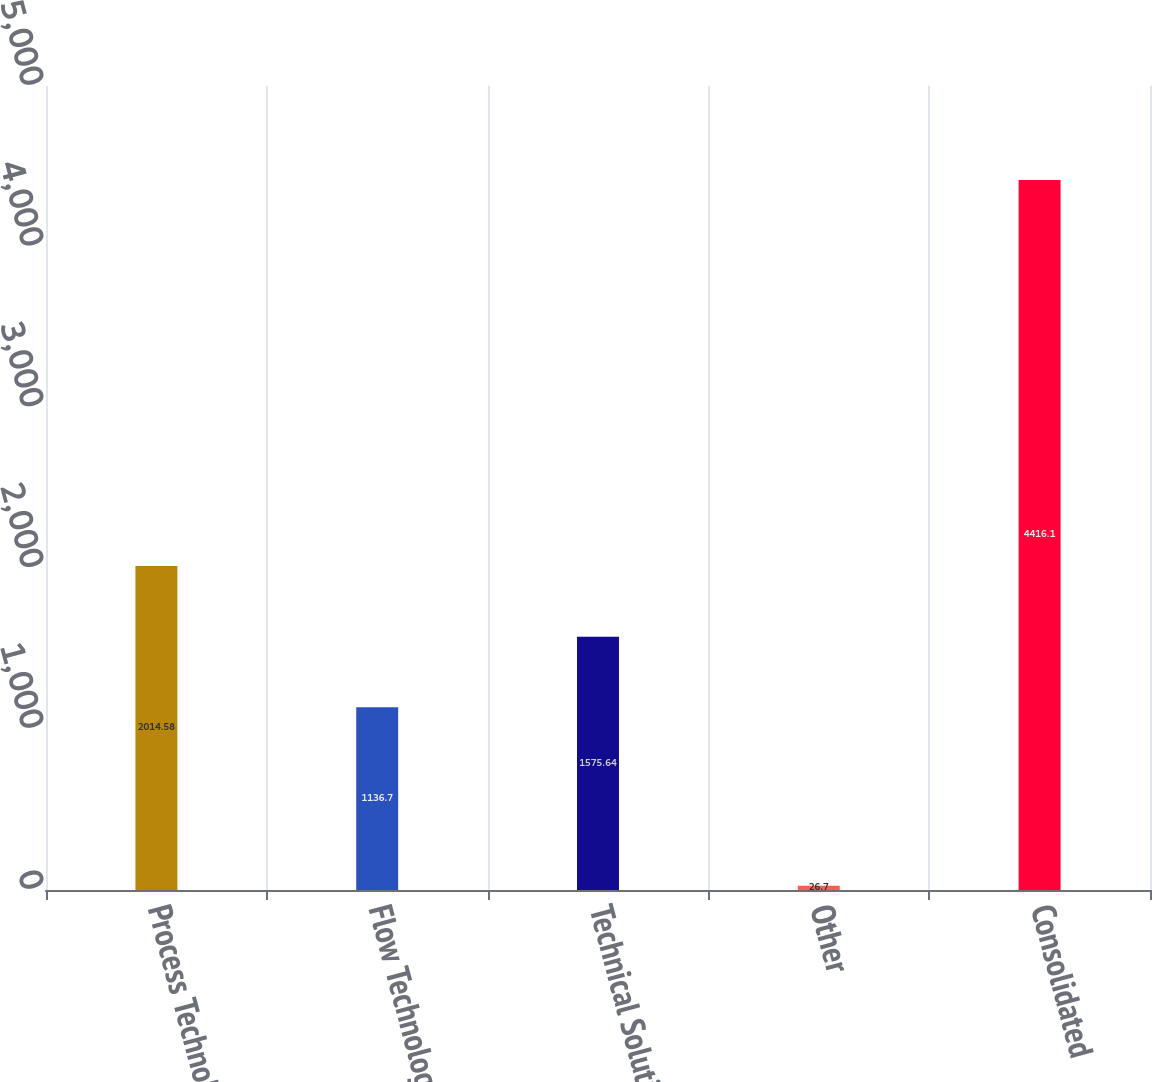<chart> <loc_0><loc_0><loc_500><loc_500><bar_chart><fcel>Process Technologies<fcel>Flow Technologies<fcel>Technical Solutions<fcel>Other<fcel>Consolidated<nl><fcel>2014.58<fcel>1136.7<fcel>1575.64<fcel>26.7<fcel>4416.1<nl></chart> 